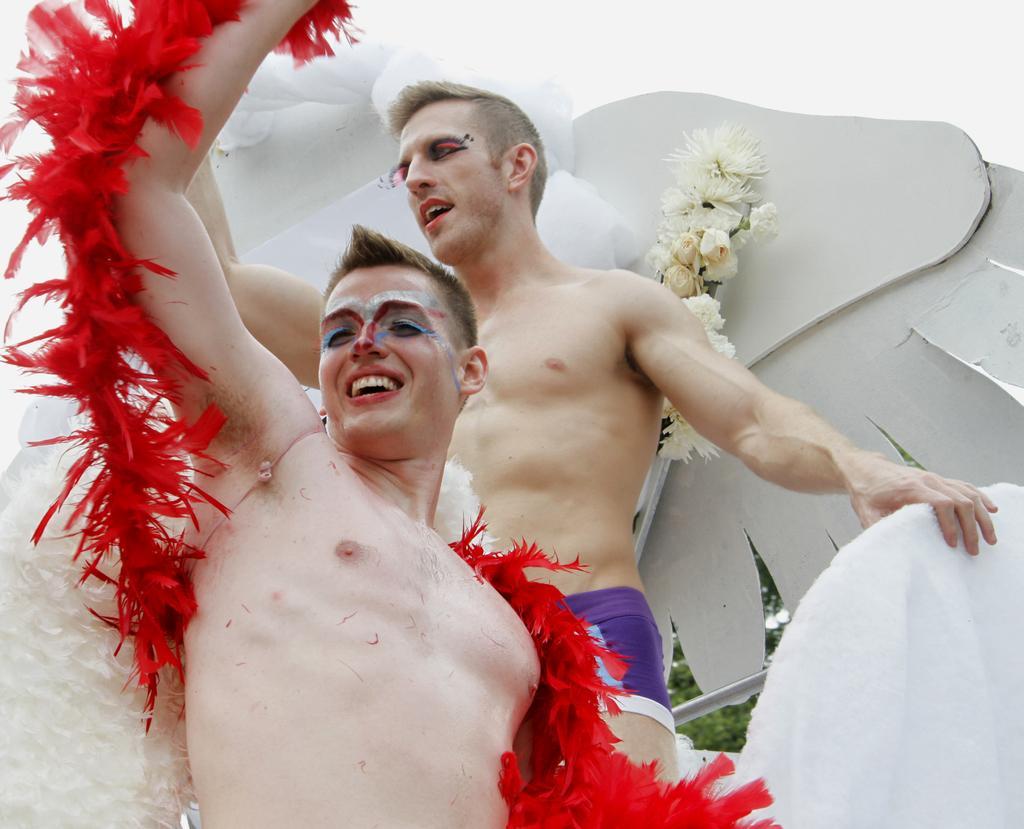Describe this image in one or two sentences. In the image we can see there are two men standing and they are wearing makeup. These are feathers and a white sky. 